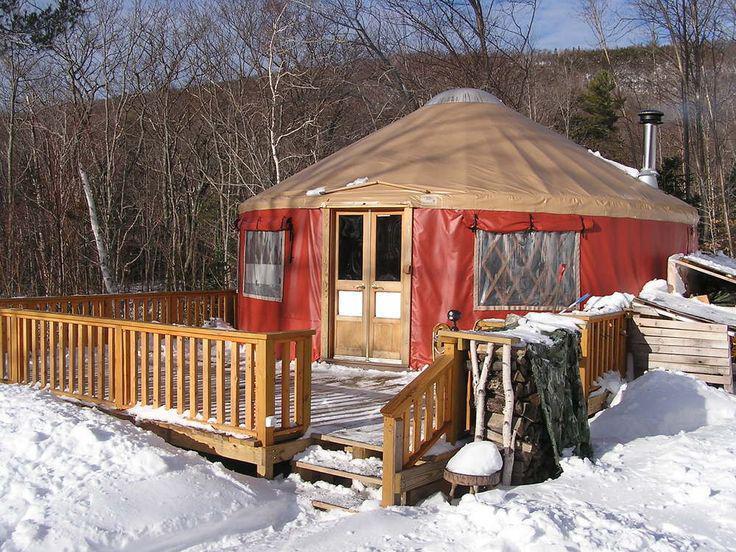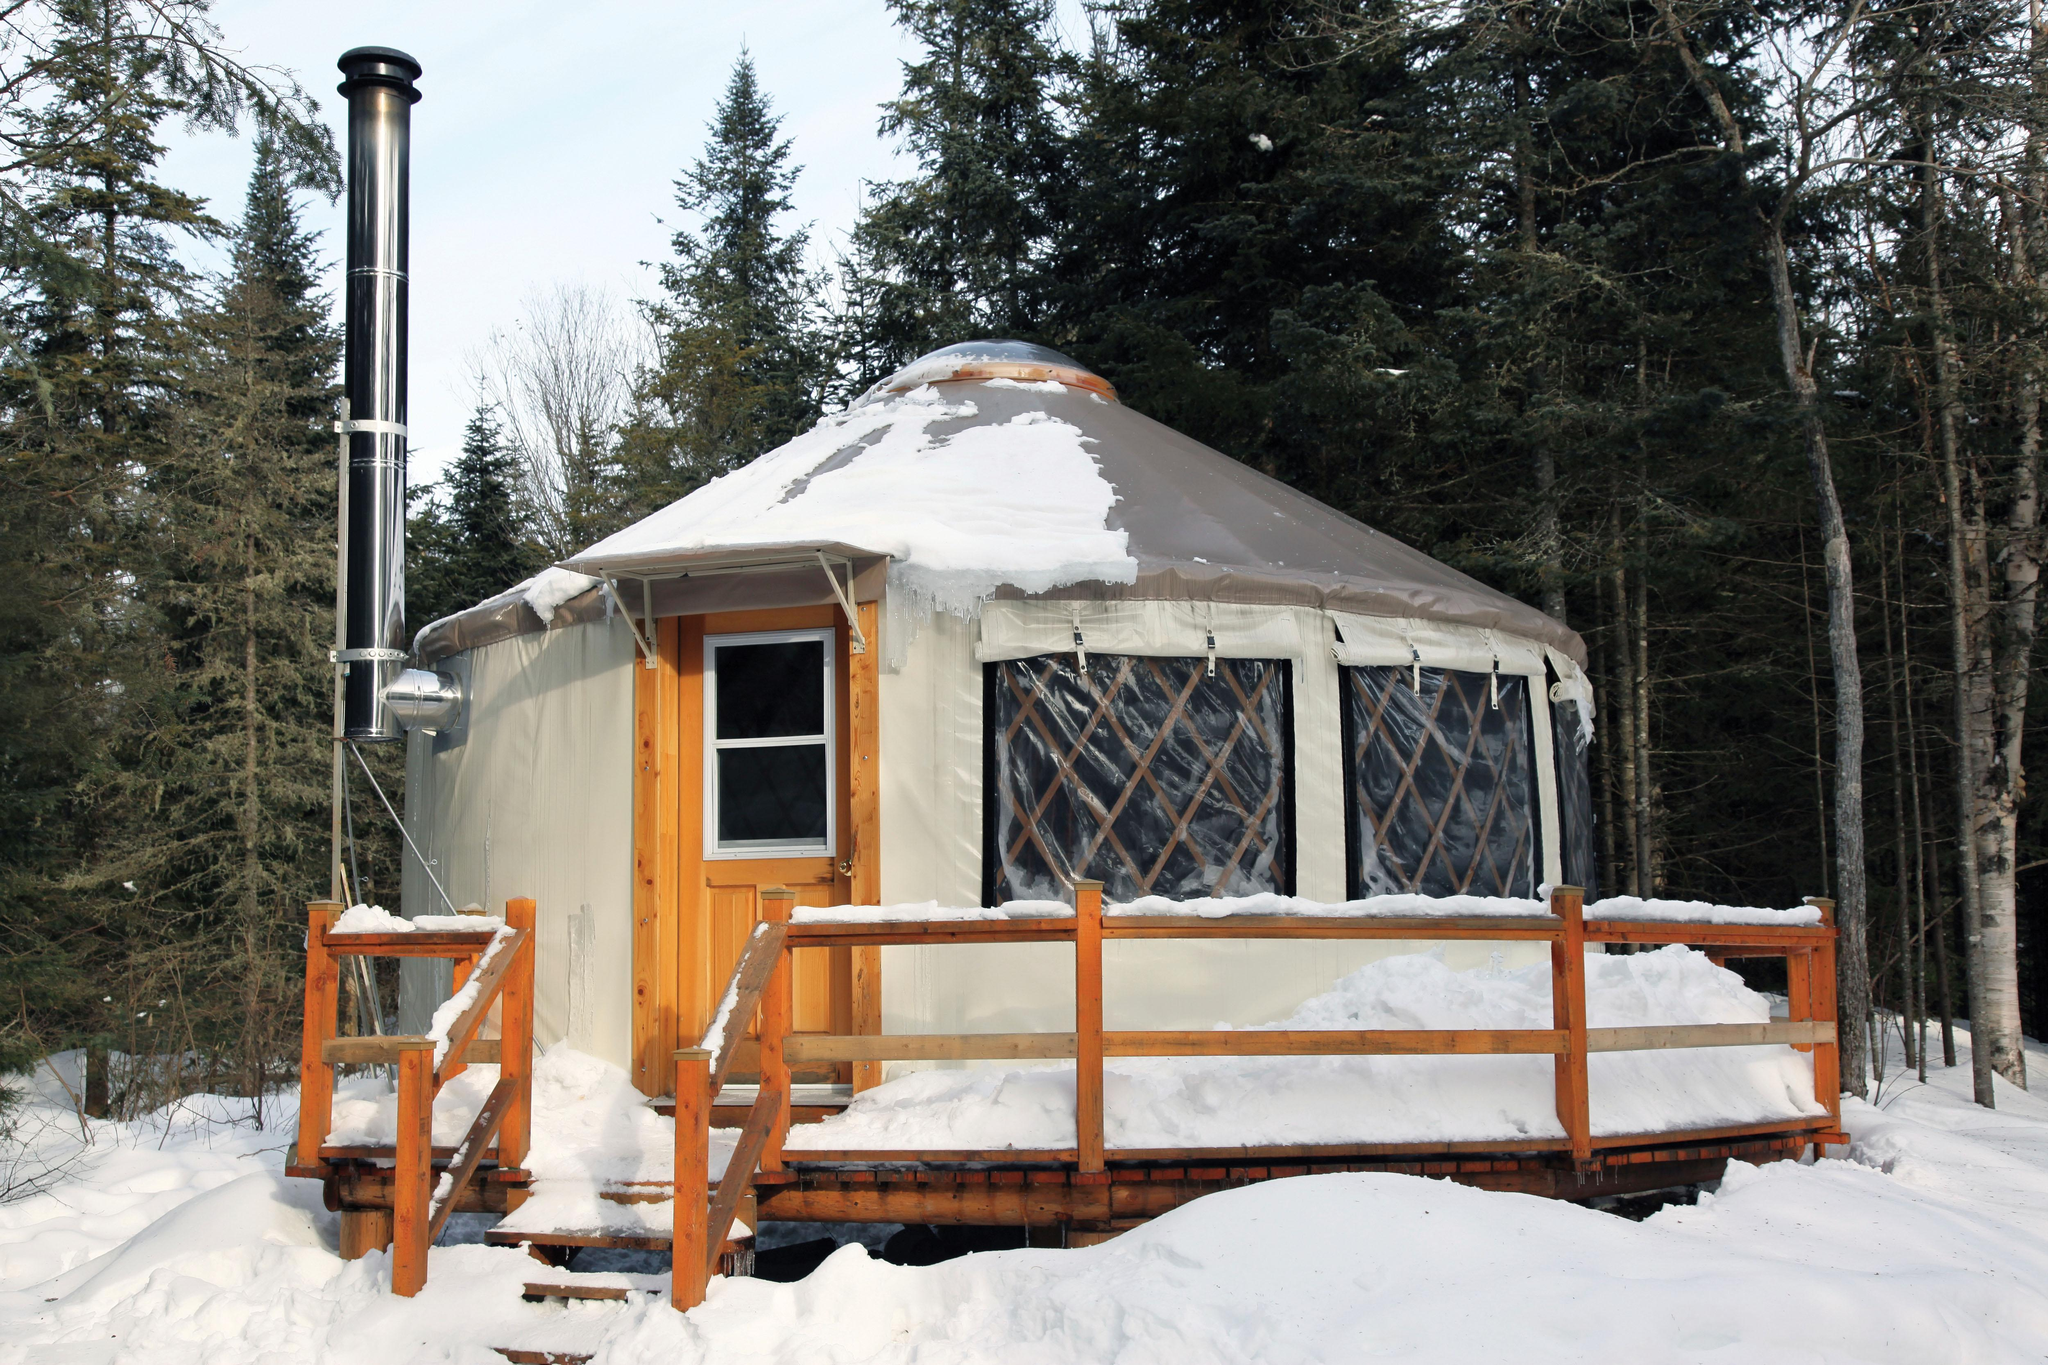The first image is the image on the left, the second image is the image on the right. Considering the images on both sides, is "Each image shows the snowy winter exterior of a yurt, with decking of wooden posts and railings." valid? Answer yes or no. Yes. The first image is the image on the left, the second image is the image on the right. Examine the images to the left and right. Is the description "An image shows a round structure surrounded by a round railed deck, and the structure has lattice-work showing in the windows." accurate? Answer yes or no. Yes. 